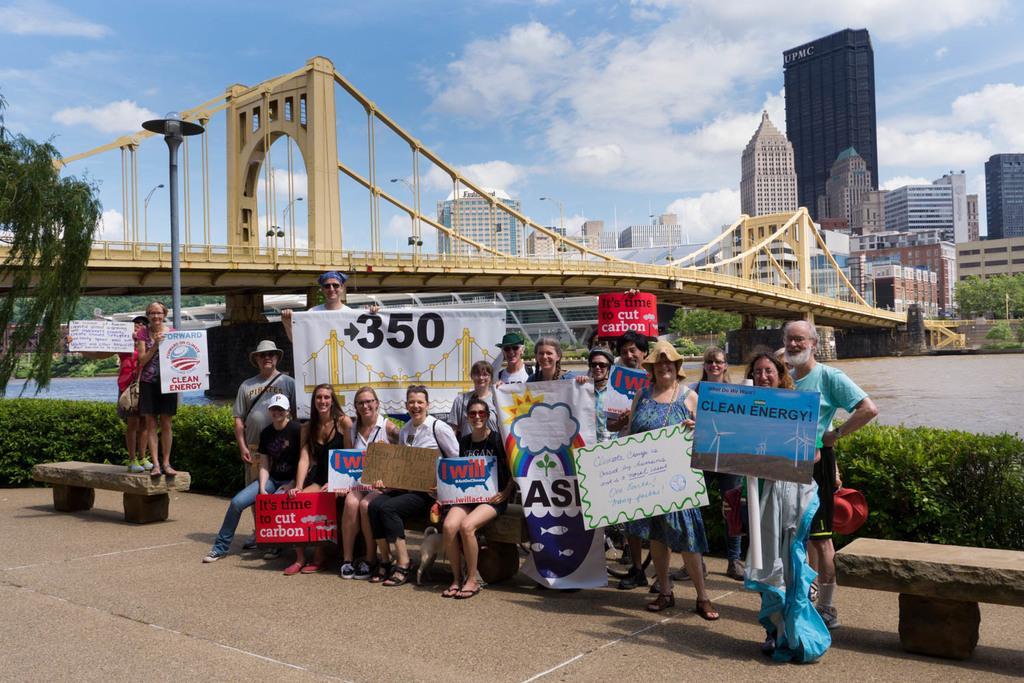Could you give a brief overview of what you see in this image? This image is taken outdoors. At the top of the image there is the sky with clouds. At the bottom of the image there is a floor. In the background there are a few buildings and there is a skyscraper. There are a few trees and plants. There is a bridge with walls, pillars and railings. On the left side of the image there is a tree and there are a few plants. In the middle of the image there is a river with water. Many people are standing on the floor and a few are sitting on the benches. Everyone is holding boards with text on them. On the right side of the image there is an empty bench on the floor. 